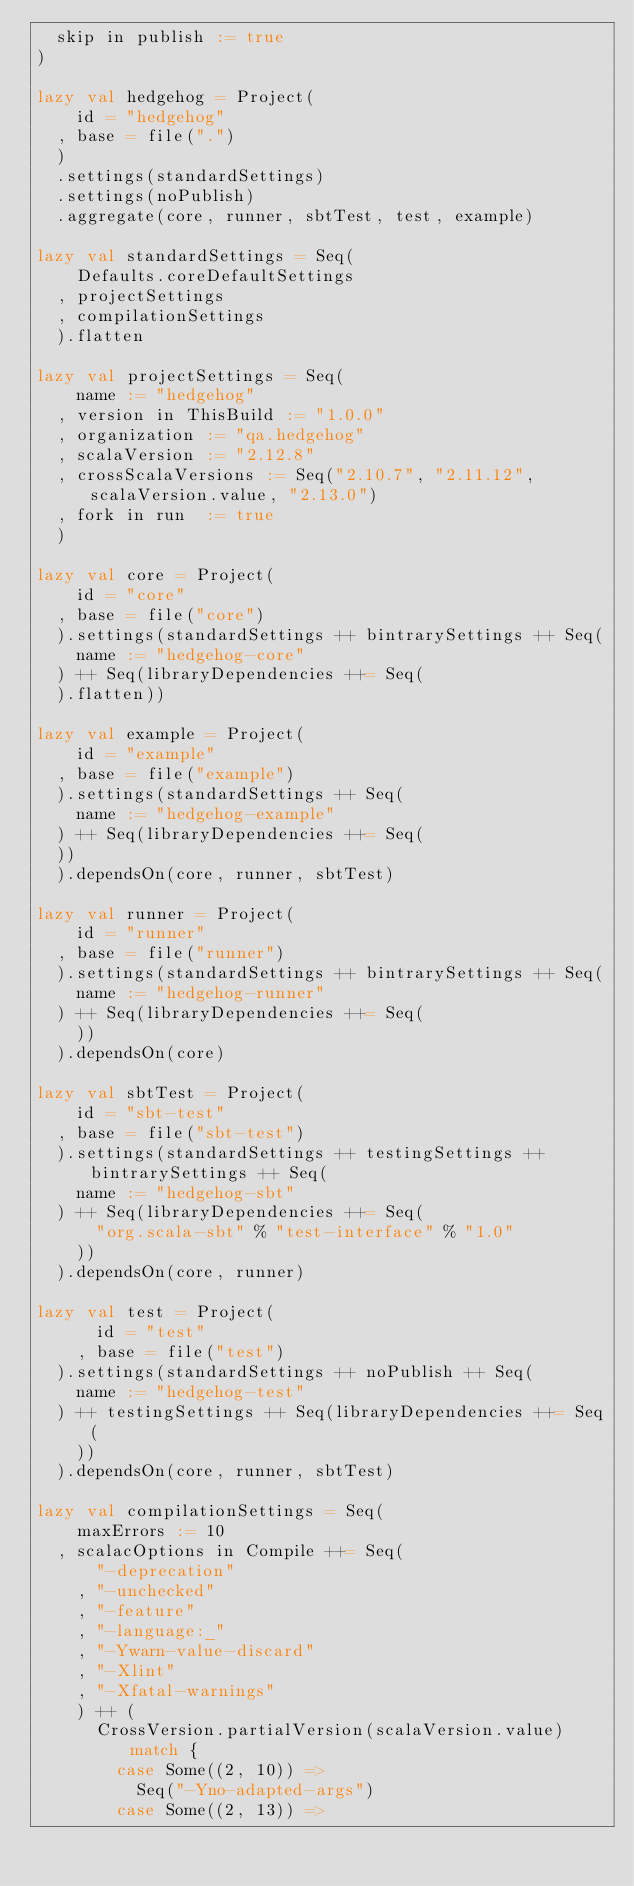<code> <loc_0><loc_0><loc_500><loc_500><_Scala_>  skip in publish := true
)

lazy val hedgehog = Project(
    id = "hedgehog"
  , base = file(".")
  )
  .settings(standardSettings)
  .settings(noPublish)
  .aggregate(core, runner, sbtTest, test, example)

lazy val standardSettings = Seq(
    Defaults.coreDefaultSettings
  , projectSettings
  , compilationSettings
  ).flatten

lazy val projectSettings = Seq(
    name := "hedgehog"
  , version in ThisBuild := "1.0.0"
  , organization := "qa.hedgehog"
  , scalaVersion := "2.12.8"
  , crossScalaVersions := Seq("2.10.7", "2.11.12", scalaVersion.value, "2.13.0")
  , fork in run  := true
  )

lazy val core = Project(
    id = "core"
  , base = file("core")
  ).settings(standardSettings ++ bintrarySettings ++ Seq(
    name := "hedgehog-core"
  ) ++ Seq(libraryDependencies ++= Seq(
  ).flatten))

lazy val example = Project(
    id = "example"
  , base = file("example")
  ).settings(standardSettings ++ Seq(
    name := "hedgehog-example"
  ) ++ Seq(libraryDependencies ++= Seq(
  ))
  ).dependsOn(core, runner, sbtTest)

lazy val runner = Project(
    id = "runner"
  , base = file("runner")
  ).settings(standardSettings ++ bintrarySettings ++ Seq(
    name := "hedgehog-runner"
  ) ++ Seq(libraryDependencies ++= Seq(
    ))
  ).dependsOn(core)

lazy val sbtTest = Project(
    id = "sbt-test"
  , base = file("sbt-test")
  ).settings(standardSettings ++ testingSettings ++ bintrarySettings ++ Seq(
    name := "hedgehog-sbt"
  ) ++ Seq(libraryDependencies ++= Seq(
      "org.scala-sbt" % "test-interface" % "1.0"
    ))
  ).dependsOn(core, runner)

lazy val test = Project(
      id = "test"
    , base = file("test")
  ).settings(standardSettings ++ noPublish ++ Seq(
    name := "hedgehog-test"
  ) ++ testingSettings ++ Seq(libraryDependencies ++= Seq(
    ))
  ).dependsOn(core, runner, sbtTest)

lazy val compilationSettings = Seq(
    maxErrors := 10
  , scalacOptions in Compile ++= Seq(
      "-deprecation"
    , "-unchecked"
    , "-feature"
    , "-language:_"
    , "-Ywarn-value-discard"
    , "-Xlint"
    , "-Xfatal-warnings"
    ) ++ (
      CrossVersion.partialVersion(scalaVersion.value) match {
        case Some((2, 10)) =>
          Seq("-Yno-adapted-args")
        case Some((2, 13)) =></code> 